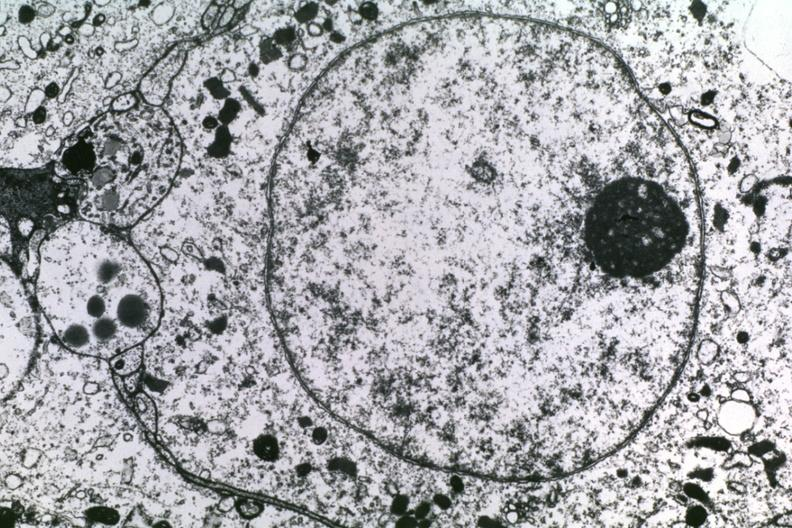s aplastic present?
Answer the question using a single word or phrase. No 